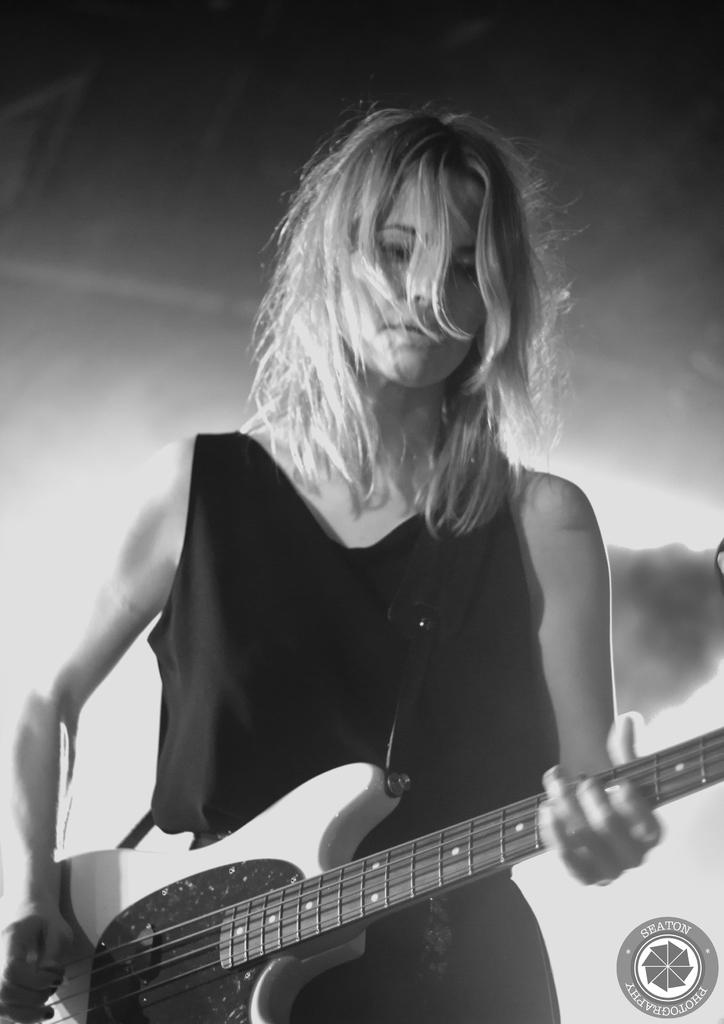Who is the main subject in the image? There is a woman in the image. What is the woman doing in the image? The woman is playing a guitar. How is the guitar being held by the woman? The guitar is in her hand. What color is the dress the woman is wearing? The woman is wearing a black dress. What book is the woman reading in the image? There is no book present in the image, and the woman is playing a guitar, not reading. 